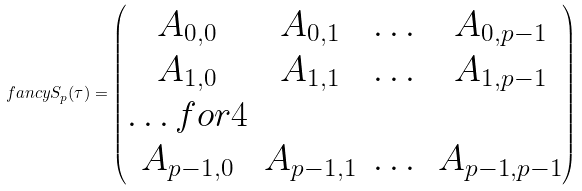Convert formula to latex. <formula><loc_0><loc_0><loc_500><loc_500>\ f a n c y S _ { p } ( \tau ) = \begin{pmatrix} A _ { 0 , 0 } & A _ { 0 , 1 } & \dots & A _ { 0 , p - 1 } \\ A _ { 1 , 0 } & A _ { 1 , 1 } & \dots & A _ { 1 , p - 1 } \\ \hdots f o r { 4 } \\ A _ { p - 1 , 0 } & A _ { p - 1 , 1 } & \dots & A _ { p - 1 , p - 1 } \end{pmatrix}</formula> 